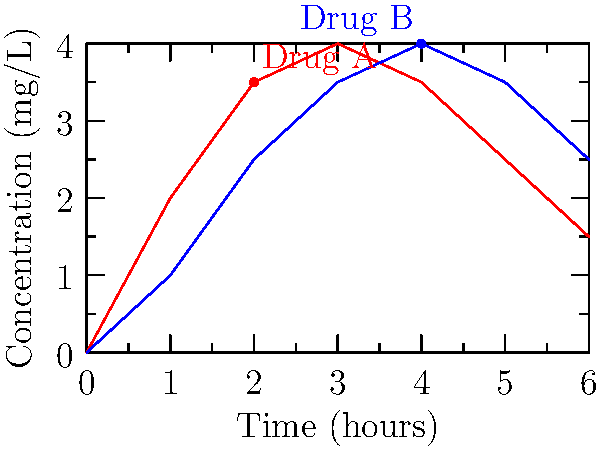The graph shows the concentration of two drugs (A and B) in the bloodstream over time. At which time point does the rate of absorption for Drug B exceed that of Drug A, and what does this indicate about the drugs' pharmacokinetics? To answer this question, we need to analyze the slopes of the concentration-time curves for both drugs:

1. The rate of absorption is represented by the slope of the concentration-time curve.
2. A steeper slope indicates a higher rate of absorption.

Let's examine the curves:

1. Drug A (red):
   - Rapid initial absorption (0-2 hours)
   - Peak concentration at 3 hours
   - Gradual decline after 3 hours

2. Drug B (blue):
   - Slower initial absorption (0-2 hours)
   - Continued increase in concentration up to 4 hours
   - Peak concentration at 4 hours

3. Comparing slopes:
   - From 0-2 hours: Drug A has a steeper slope
   - From 2-4 hours: Drug B's slope becomes steeper than Drug A's

4. The crossover point occurs at approximately 2 hours, where Drug B's absorption rate exceeds Drug A's.

5. Pharmacokinetic implications:
   - Drug A: Faster initial absorption, earlier peak, faster elimination
   - Drug B: Slower initial absorption, later peak, potentially longer duration of action

This difference in absorption rates could be due to various factors such as formulation, route of administration, or drug properties affecting dissolution and absorption.
Answer: 2 hours; Drug B has slower initial absorption but sustained release compared to Drug A. 